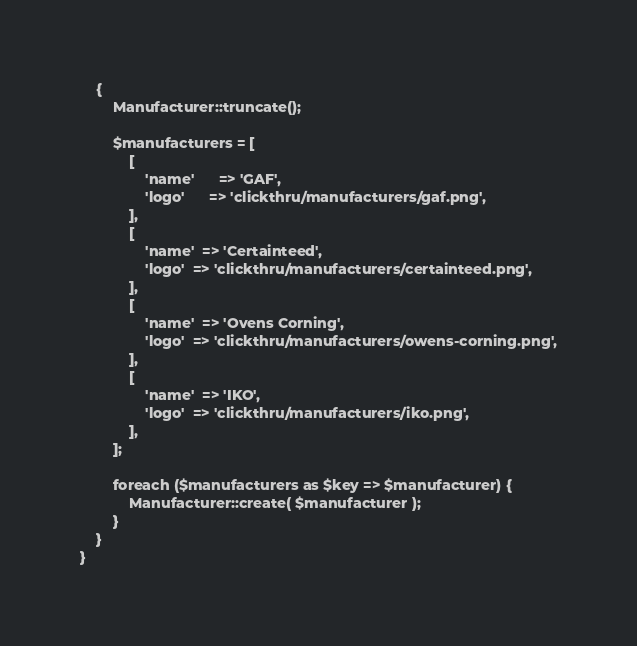<code> <loc_0><loc_0><loc_500><loc_500><_PHP_>	{
        Manufacturer::truncate();

		$manufacturers = [
			[
				'name' 		=> 'GAF',
				'logo' 		=> 'clickthru/manufacturers/gaf.png',
			],
			[
				'name' 	=> 'Certainteed',
				'logo' 	=> 'clickthru/manufacturers/certainteed.png',
			],
			[
				'name' 	=> 'Ovens Corning',
				'logo' 	=> 'clickthru/manufacturers/owens-corning.png',
			],
			[
				'name' 	=> 'IKO',
				'logo' 	=> 'clickthru/manufacturers/iko.png',
			],
        ];

		foreach ($manufacturers as $key => $manufacturer) {
			Manufacturer::create( $manufacturer );
		}
	}
}</code> 